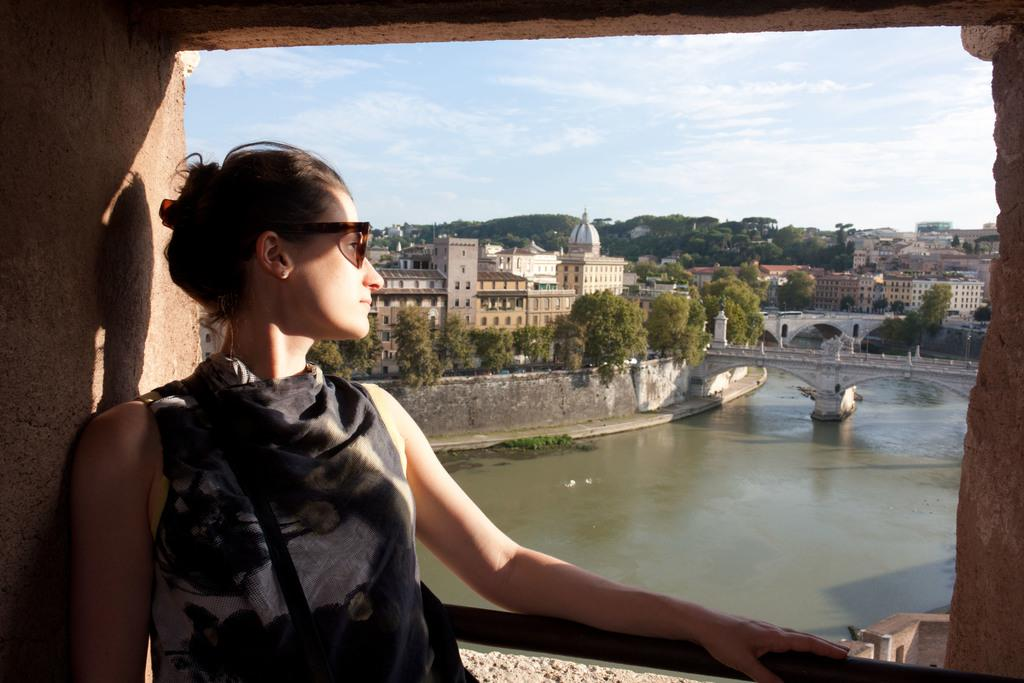What is the main subject in the foreground of the image? There is a woman standing in the foreground of the image. What can be seen in the background of the image? There is a water surface, a bridge, trees, and buildings visible in the image. What type of skirt is the woman wearing in the image? The facts provided do not mention the woman's clothing, so we cannot determine if she is wearing a skirt or any other type of clothing. 